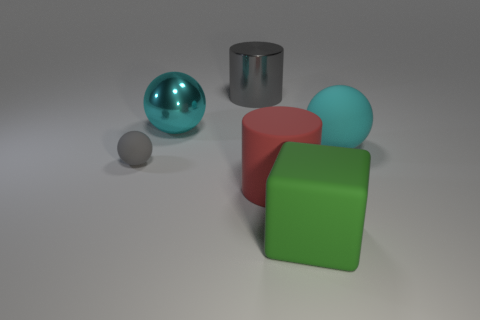There is a matte ball to the right of the big block; is its color the same as the large sphere that is left of the large gray thing?
Your answer should be very brief. Yes. Are there any matte cylinders in front of the red cylinder?
Provide a succinct answer. No. There is a object that is behind the small gray rubber thing and left of the big metal cylinder; what color is it?
Offer a very short reply. Cyan. Are there any metallic cylinders of the same color as the large matte ball?
Make the answer very short. No. Is the object behind the big cyan metallic ball made of the same material as the cylinder in front of the gray shiny cylinder?
Ensure brevity in your answer.  No. What is the size of the gray object right of the small gray rubber sphere?
Keep it short and to the point. Large. How big is the gray metallic object?
Your response must be concise. Large. What is the size of the ball behind the cyan ball in front of the large cyan object on the left side of the green cube?
Your response must be concise. Large. Are there any tiny brown cylinders made of the same material as the large gray object?
Your answer should be compact. No. What shape is the big green object?
Offer a very short reply. Cube. 